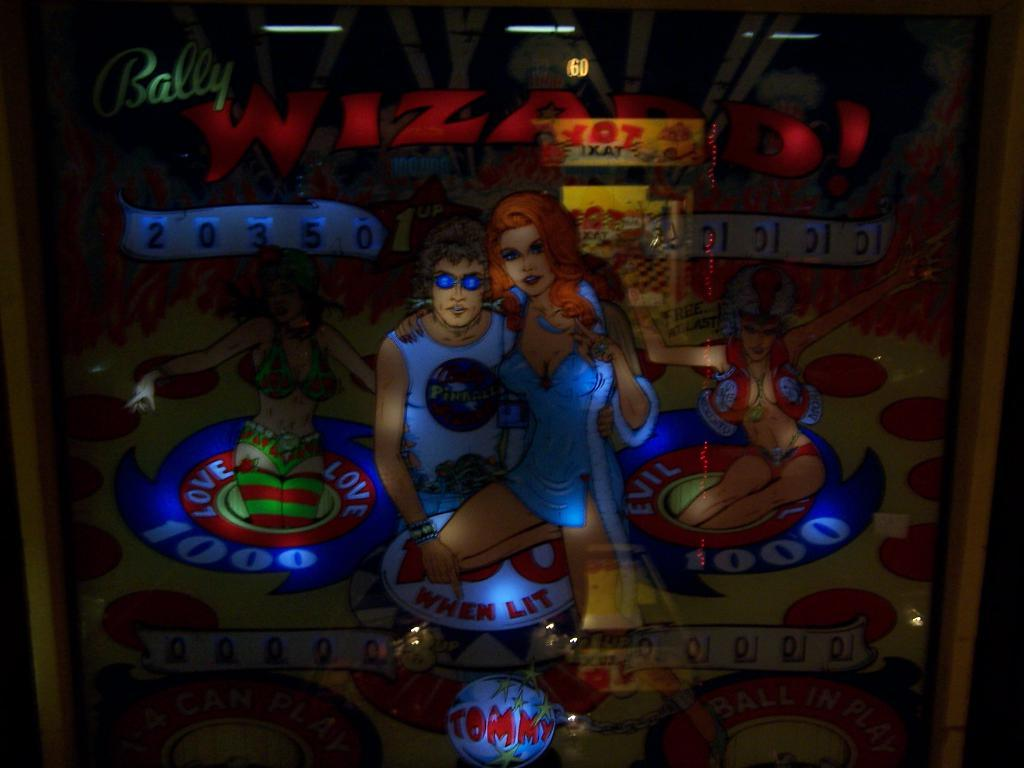<image>
Summarize the visual content of the image. close of of bally pinball machine decorated with tommy pinball wizard 